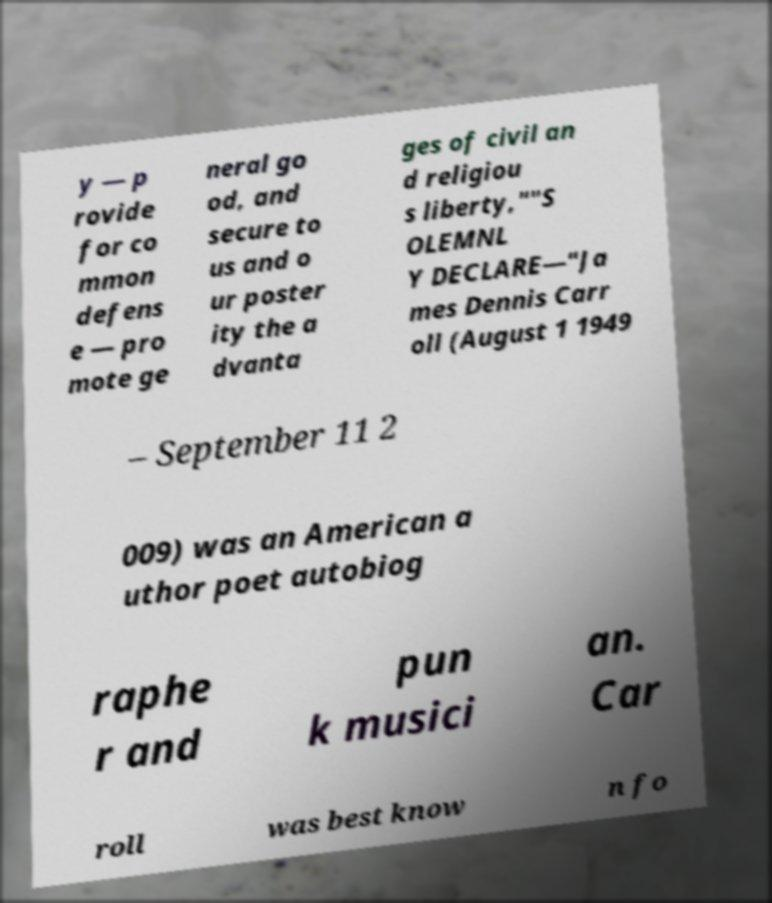For documentation purposes, I need the text within this image transcribed. Could you provide that? y — p rovide for co mmon defens e — pro mote ge neral go od, and secure to us and o ur poster ity the a dvanta ges of civil an d religiou s liberty,""S OLEMNL Y DECLARE—"Ja mes Dennis Carr oll (August 1 1949 – September 11 2 009) was an American a uthor poet autobiog raphe r and pun k musici an. Car roll was best know n fo 